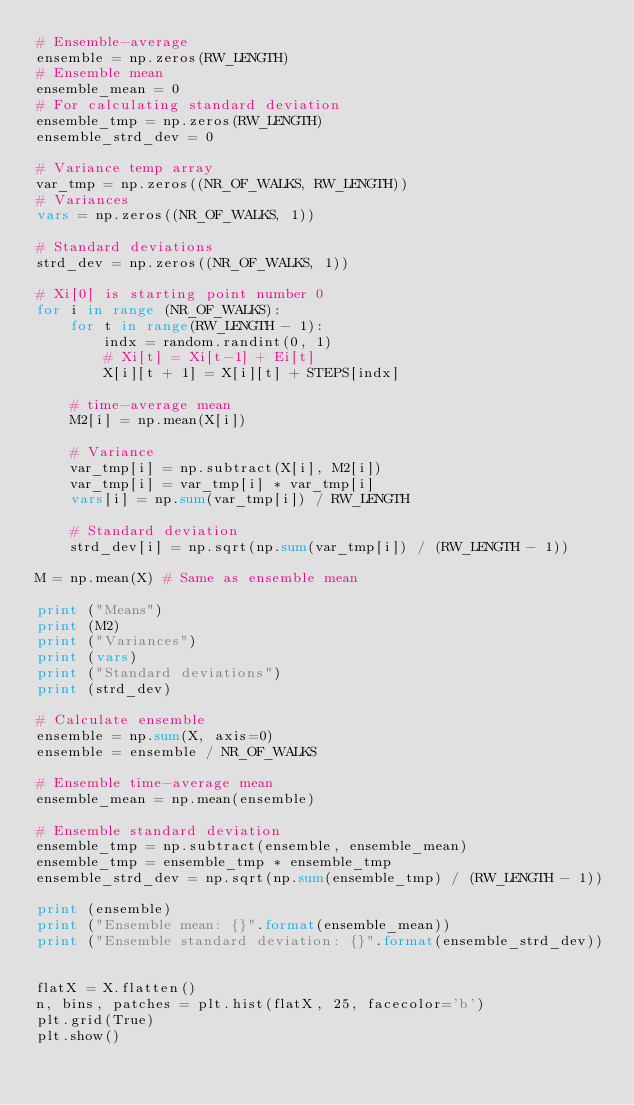Convert code to text. <code><loc_0><loc_0><loc_500><loc_500><_Python_># Ensemble-average
ensemble = np.zeros(RW_LENGTH)
# Ensemble mean
ensemble_mean = 0
# For calculating standard deviation
ensemble_tmp = np.zeros(RW_LENGTH)
ensemble_strd_dev = 0

# Variance temp array
var_tmp = np.zeros((NR_OF_WALKS, RW_LENGTH))
# Variances
vars = np.zeros((NR_OF_WALKS, 1))

# Standard deviations
strd_dev = np.zeros((NR_OF_WALKS, 1))

# Xi[0] is starting point number 0
for i in range (NR_OF_WALKS):
    for t in range(RW_LENGTH - 1):
        indx = random.randint(0, 1)
        # Xi[t] = Xi[t-1] + Ei[t]
        X[i][t + 1] = X[i][t] + STEPS[indx]
    
    # time-average mean
    M2[i] = np.mean(X[i])

    # Variance
    var_tmp[i] = np.subtract(X[i], M2[i])
    var_tmp[i] = var_tmp[i] * var_tmp[i]
    vars[i] = np.sum(var_tmp[i]) / RW_LENGTH

    # Standard deviation
    strd_dev[i] = np.sqrt(np.sum(var_tmp[i]) / (RW_LENGTH - 1))

M = np.mean(X) # Same as ensemble mean

print ("Means")
print (M2)
print ("Variances")
print (vars)
print ("Standard deviations")
print (strd_dev)

# Calculate ensemble
ensemble = np.sum(X, axis=0)
ensemble = ensemble / NR_OF_WALKS

# Ensemble time-average mean
ensemble_mean = np.mean(ensemble)

# Ensemble standard deviation
ensemble_tmp = np.subtract(ensemble, ensemble_mean)
ensemble_tmp = ensemble_tmp * ensemble_tmp
ensemble_strd_dev = np.sqrt(np.sum(ensemble_tmp) / (RW_LENGTH - 1))

print (ensemble)
print ("Ensemble mean: {}".format(ensemble_mean))
print ("Ensemble standard deviation: {}".format(ensemble_strd_dev))


flatX = X.flatten()
n, bins, patches = plt.hist(flatX, 25, facecolor='b')
plt.grid(True)
plt.show()
</code> 